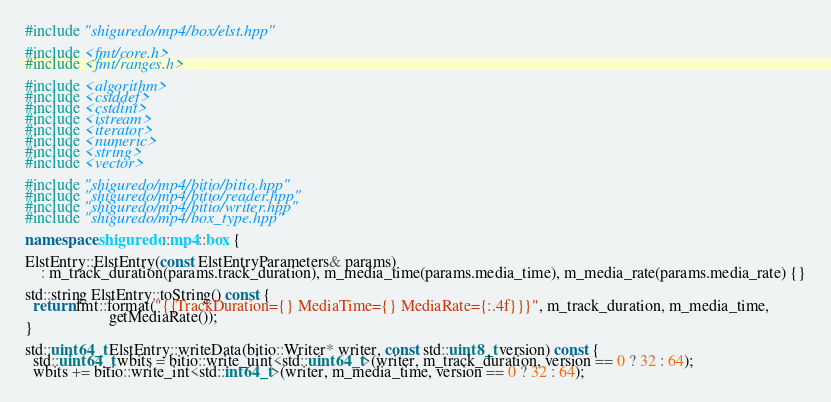<code> <loc_0><loc_0><loc_500><loc_500><_C++_>#include "shiguredo/mp4/box/elst.hpp"

#include <fmt/core.h>
#include <fmt/ranges.h>

#include <algorithm>
#include <cstddef>
#include <cstdint>
#include <istream>
#include <iterator>
#include <numeric>
#include <string>
#include <vector>

#include "shiguredo/mp4/bitio/bitio.hpp"
#include "shiguredo/mp4/bitio/reader.hpp"
#include "shiguredo/mp4/bitio/writer.hpp"
#include "shiguredo/mp4/box_type.hpp"

namespace shiguredo::mp4::box {

ElstEntry::ElstEntry(const ElstEntryParameters& params)
    : m_track_duration(params.track_duration), m_media_time(params.media_time), m_media_rate(params.media_rate) {}

std::string ElstEntry::toString() const {
  return fmt::format("{{TrackDuration={} MediaTime={} MediaRate={:.4f}}}", m_track_duration, m_media_time,
                     getMediaRate());
}

std::uint64_t ElstEntry::writeData(bitio::Writer* writer, const std::uint8_t version) const {
  std::uint64_t wbits = bitio::write_uint<std::uint64_t>(writer, m_track_duration, version == 0 ? 32 : 64);
  wbits += bitio::write_int<std::int64_t>(writer, m_media_time, version == 0 ? 32 : 64);</code> 